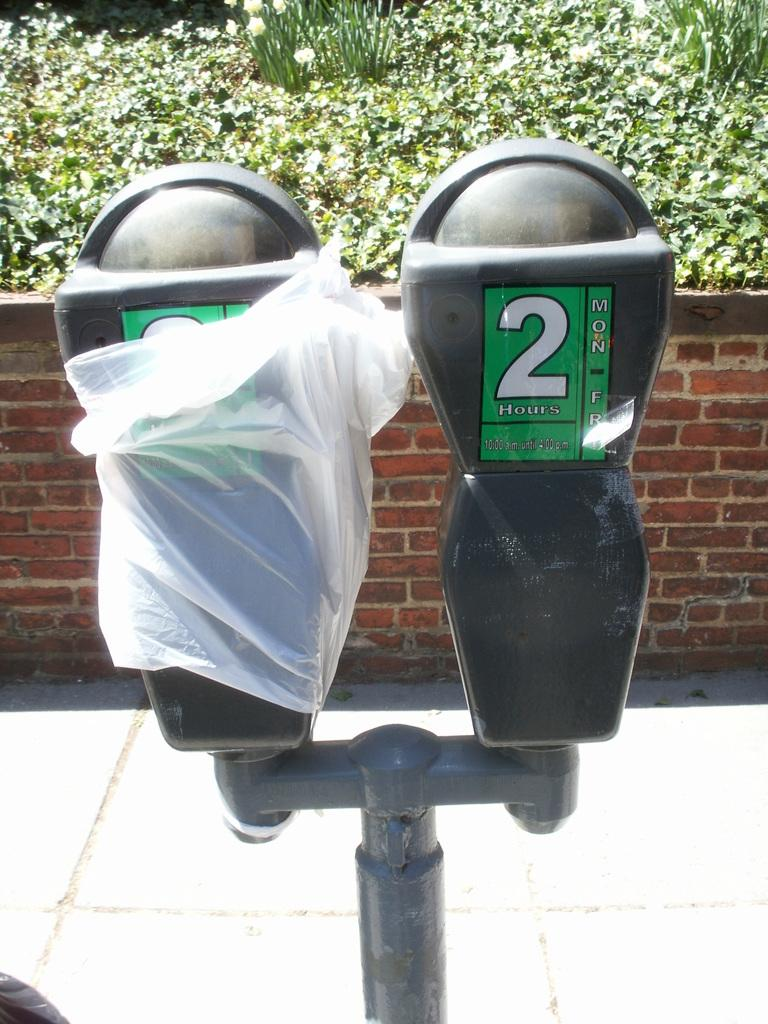<image>
Describe the image concisely. A parking meter with the number 2 on it has a plastic bag covering one side. 